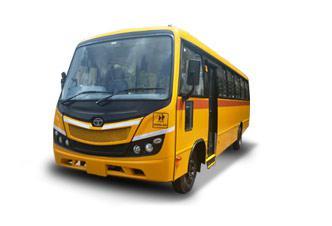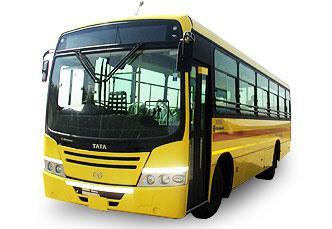The first image is the image on the left, the second image is the image on the right. Considering the images on both sides, is "Both yellow buses are facing the same direction." valid? Answer yes or no. Yes. The first image is the image on the left, the second image is the image on the right. Evaluate the accuracy of this statement regarding the images: "The vehicles are facing in the same direction.". Is it true? Answer yes or no. Yes. 